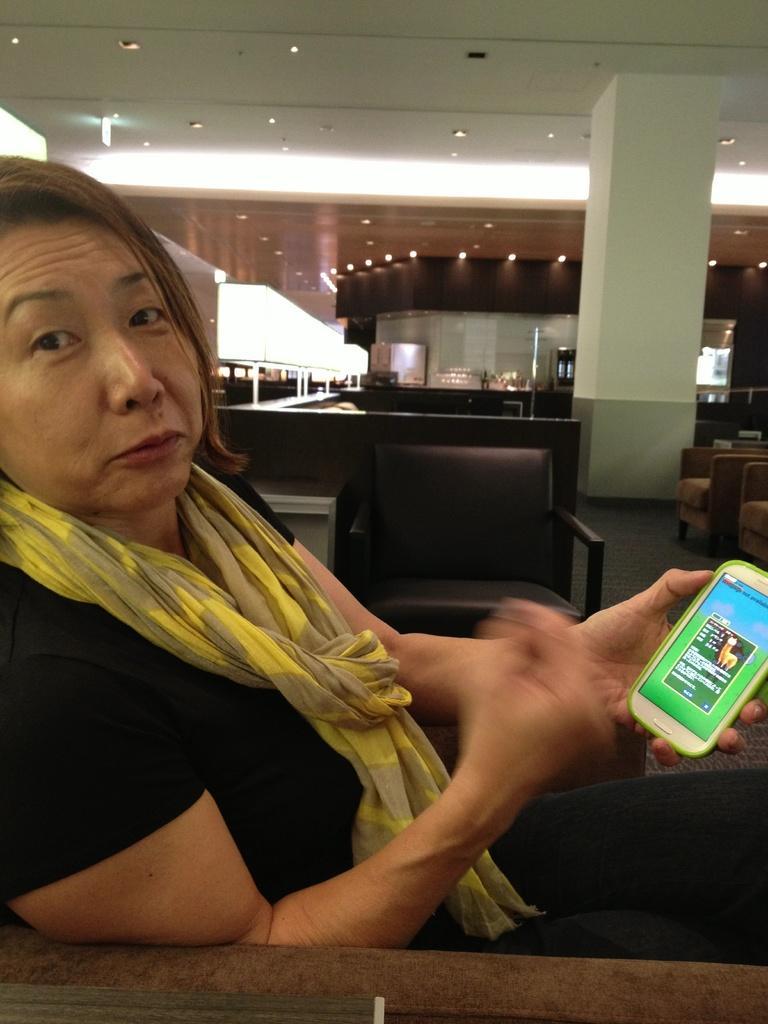In one or two sentences, can you explain what this image depicts? In this picture we can a lady wearing a stole around his neck. She is wearing a black t-shirt. On her left hand she is holding an android mobile phone. We can see black chair in the middle. In the background we can see reception kind of thing. TO the right most corner there are some sofas. And we can also see a pillar. And to the top of that roof we can see small lights. 